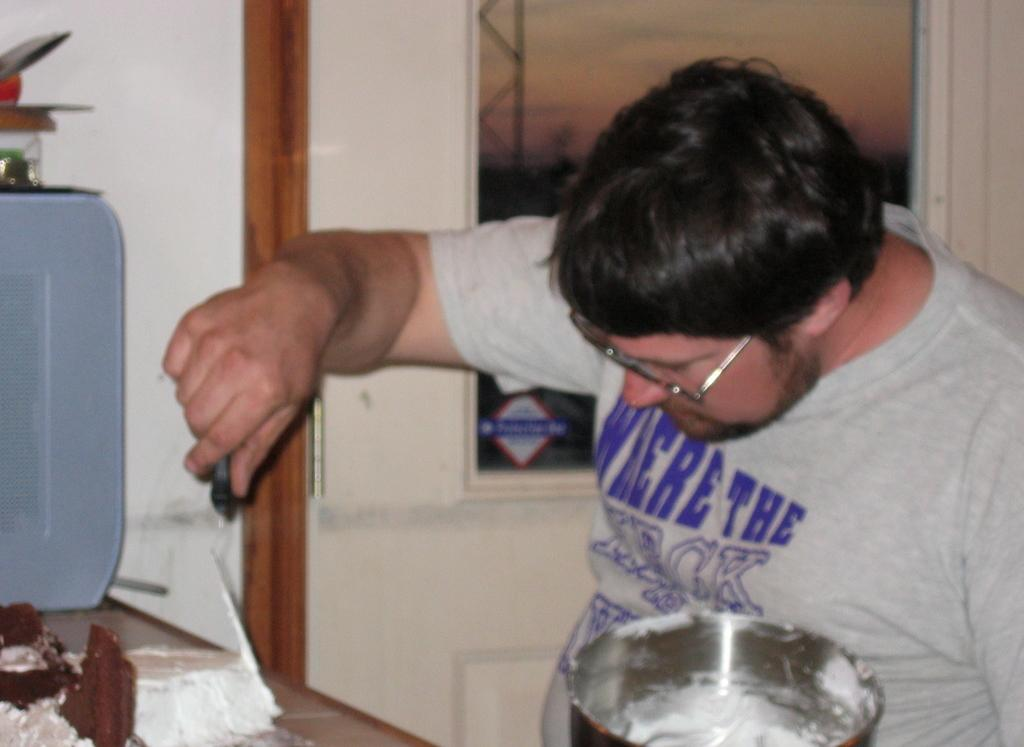<image>
Summarize the visual content of the image. a man wearing a where the heck t-shirt is frosting a cake 